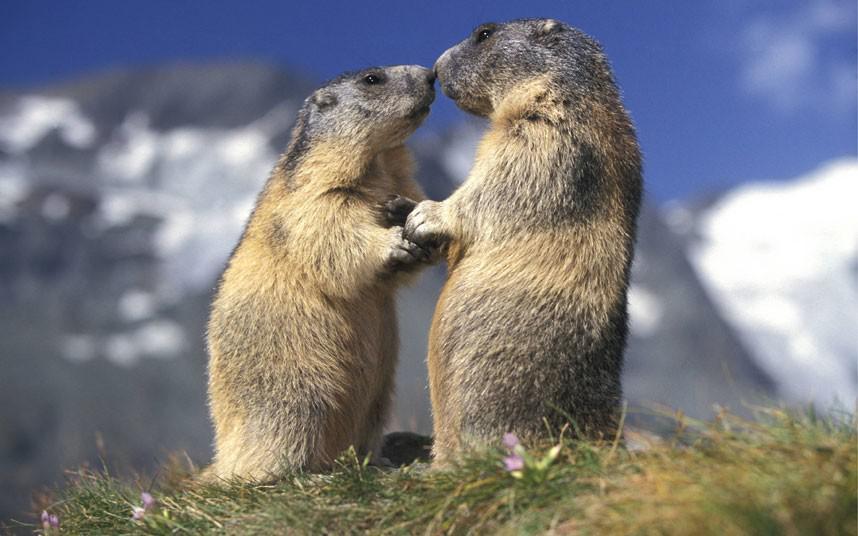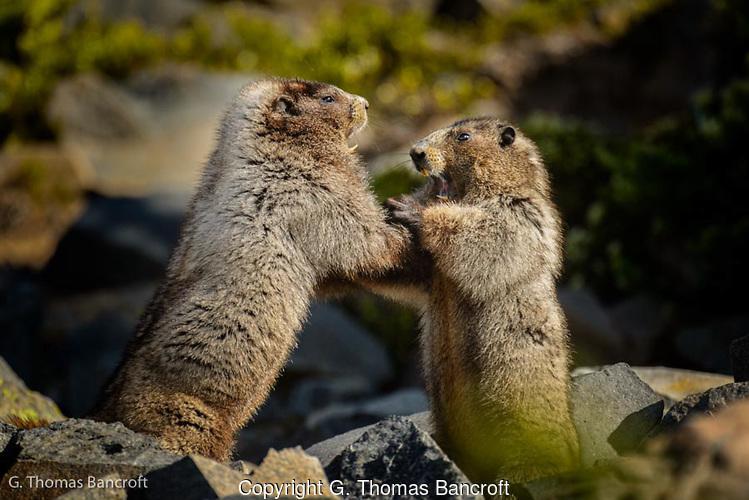The first image is the image on the left, the second image is the image on the right. Evaluate the accuracy of this statement regarding the images: "Left image contains two marmots, which are upright and posed together, and the one on the left of the picture looks shorter than the marmot on the right.". Is it true? Answer yes or no. Yes. The first image is the image on the left, the second image is the image on the right. For the images displayed, is the sentence "The animals in the image on the right are standing on their hind legs." factually correct? Answer yes or no. Yes. 